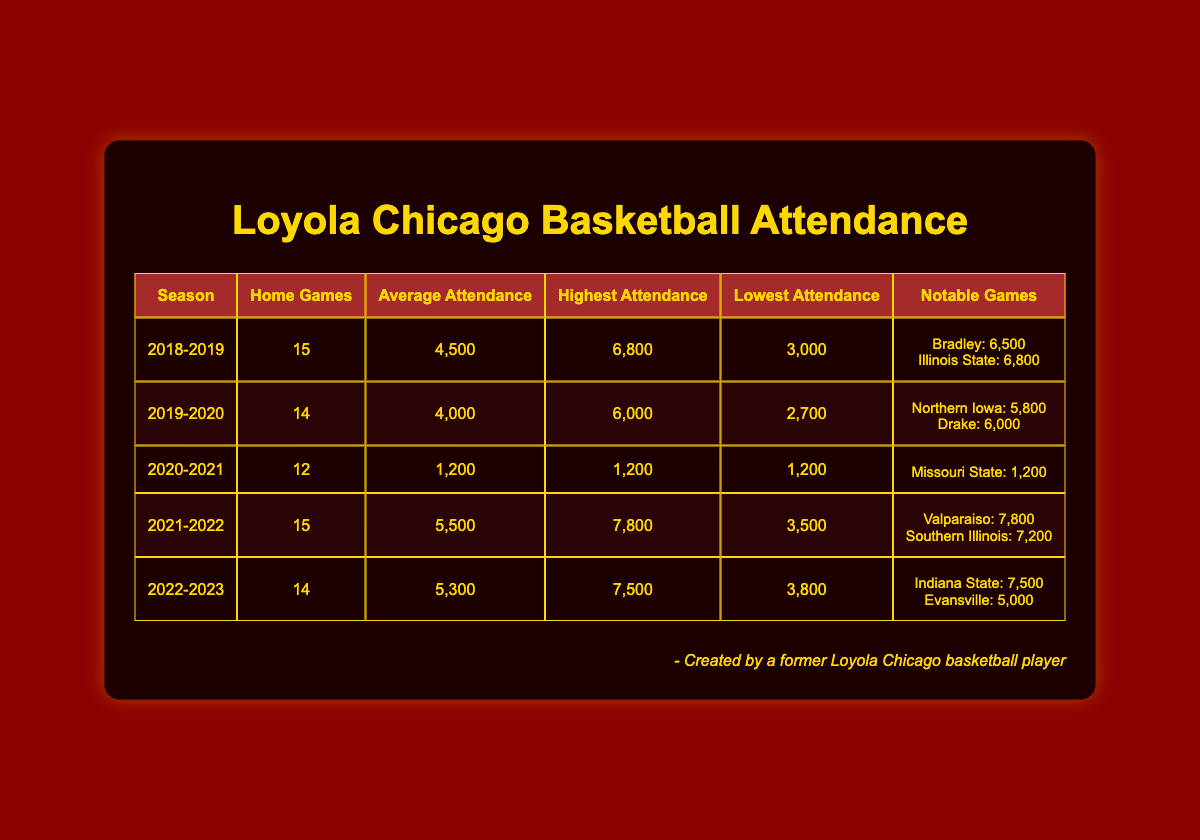What was the highest attendance for Loyola Chicago in the 2021-2022 season? The table shows that the highest attendance during the 2021-2022 season was 7,800.
Answer: 7,800 What is the average attendance for Loyola Chicago over the five seasons? To find the average attendance, sum the average attendances across all seasons: (4500 + 4000 + 1200 + 5500 + 5300) = 20700. Then divide by the number of seasons: 20700 / 5 = 4140.
Answer: 4,140 In which season did Loyola Chicago have the lowest average attendance? The lowest average attendance was in the 2020-2021 season, which had an average of 1,200.
Answer: 2020-2021 Did Loyola Chicago have a game with an attendance of over 6,000 in the 2019-2020 season? Yes, the table indicates that there were two games with attendance over 6,000 in the 2019-2020 season: one against Northern Iowa at 5,800 and another against Drake at 6,000, but the highest was actually below 6,000, thus false.
Answer: No Which season had the largest difference between the highest and lowest attendance? For each season, calculate the difference between highest and lowest attendance: 2018-2019 (6800 - 3000 = 3800), 2019-2020 (6000 - 2700 = 3300), 2020-2021 (1200 - 1200 = 0), 2021-2022 (7800 - 3500 = 4300), and 2022-2023 (7500 - 3800 = 3700). The largest difference is in the 2021-2022 season with a difference of 4,300.
Answer: 2021-2022 How many home games did Loyola Chicago have in total over these five seasons? The total number of home games can be found by summing the home games over all seasons: 15 + 14 + 12 + 15 + 14 = 70.
Answer: 70 Was the notable game against Valparaiso the game with the highest attendance in 2021-2022? Yes, according to the table, the notable game against Valparaiso had an attendance of 7,800, which is the highest attendance recorded for that season.
Answer: Yes In which season did Loyola Chicago play the fewest home games? The 2020-2021 season had the fewest home games, with only 12 games scheduled.
Answer: 2020-2021 Which opponent had the highest attendance in a game against Loyola Chicago? The opponent Illinois State had the highest attendance against Loyola Chicago, drawing 6,800 fans in the 2018-2019 season.
Answer: Illinois State 